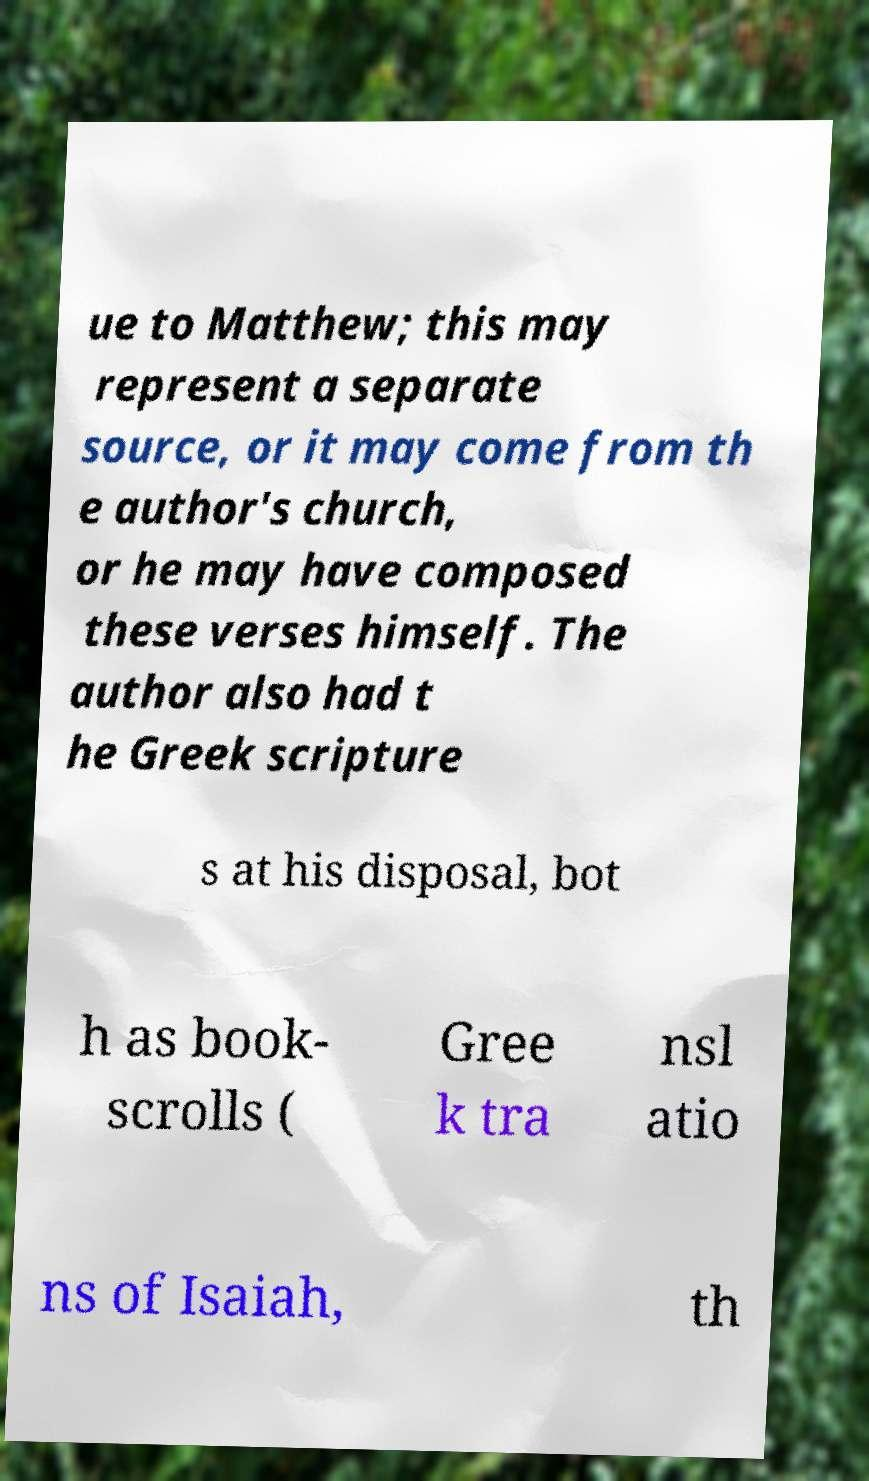Could you extract and type out the text from this image? ue to Matthew; this may represent a separate source, or it may come from th e author's church, or he may have composed these verses himself. The author also had t he Greek scripture s at his disposal, bot h as book- scrolls ( Gree k tra nsl atio ns of Isaiah, th 